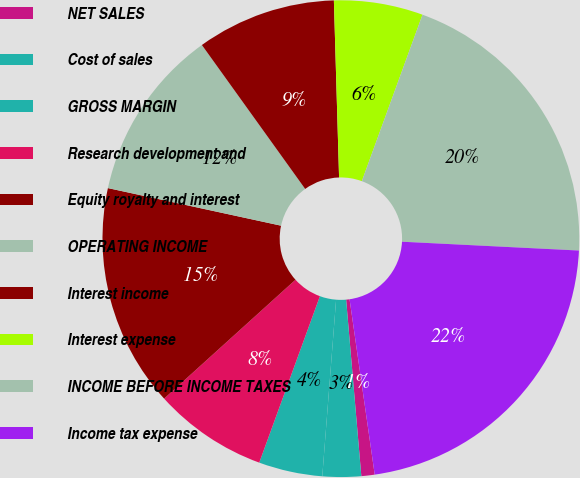<chart> <loc_0><loc_0><loc_500><loc_500><pie_chart><fcel>NET SALES<fcel>Cost of sales<fcel>GROSS MARGIN<fcel>Research development and<fcel>Equity royalty and interest<fcel>OPERATING INCOME<fcel>Interest income<fcel>Interest expense<fcel>INCOME BEFORE INCOME TAXES<fcel>Income tax expense<nl><fcel>0.9%<fcel>2.61%<fcel>4.32%<fcel>7.73%<fcel>15.11%<fcel>11.69%<fcel>9.44%<fcel>6.03%<fcel>20.23%<fcel>21.94%<nl></chart> 